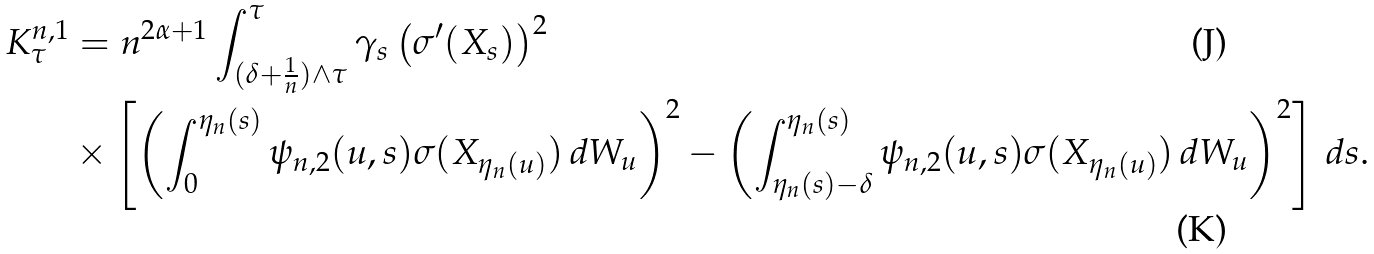<formula> <loc_0><loc_0><loc_500><loc_500>K ^ { n , 1 } _ { \tau } & = n ^ { 2 \alpha + 1 } \int ^ { \tau } _ { ( \delta + \frac { 1 } { n } ) \wedge \tau } \gamma _ { s } \left ( \sigma ^ { \prime } ( X _ { s } ) \right ) ^ { 2 } \\ & \times \left [ \left ( \int _ { 0 } ^ { \eta _ { n } ( s ) } \psi _ { n , 2 } ( u , s ) \sigma ( X _ { \eta _ { n } ( u ) } ) \, d W _ { u } \right ) ^ { 2 } - \left ( \int _ { \eta _ { n } ( s ) - \delta } ^ { \eta _ { n } ( s ) } \psi _ { n , 2 } ( u , s ) \sigma ( X _ { \eta _ { n } ( u ) } ) \, d W _ { u } \right ) ^ { 2 } \right ] \, d s .</formula> 